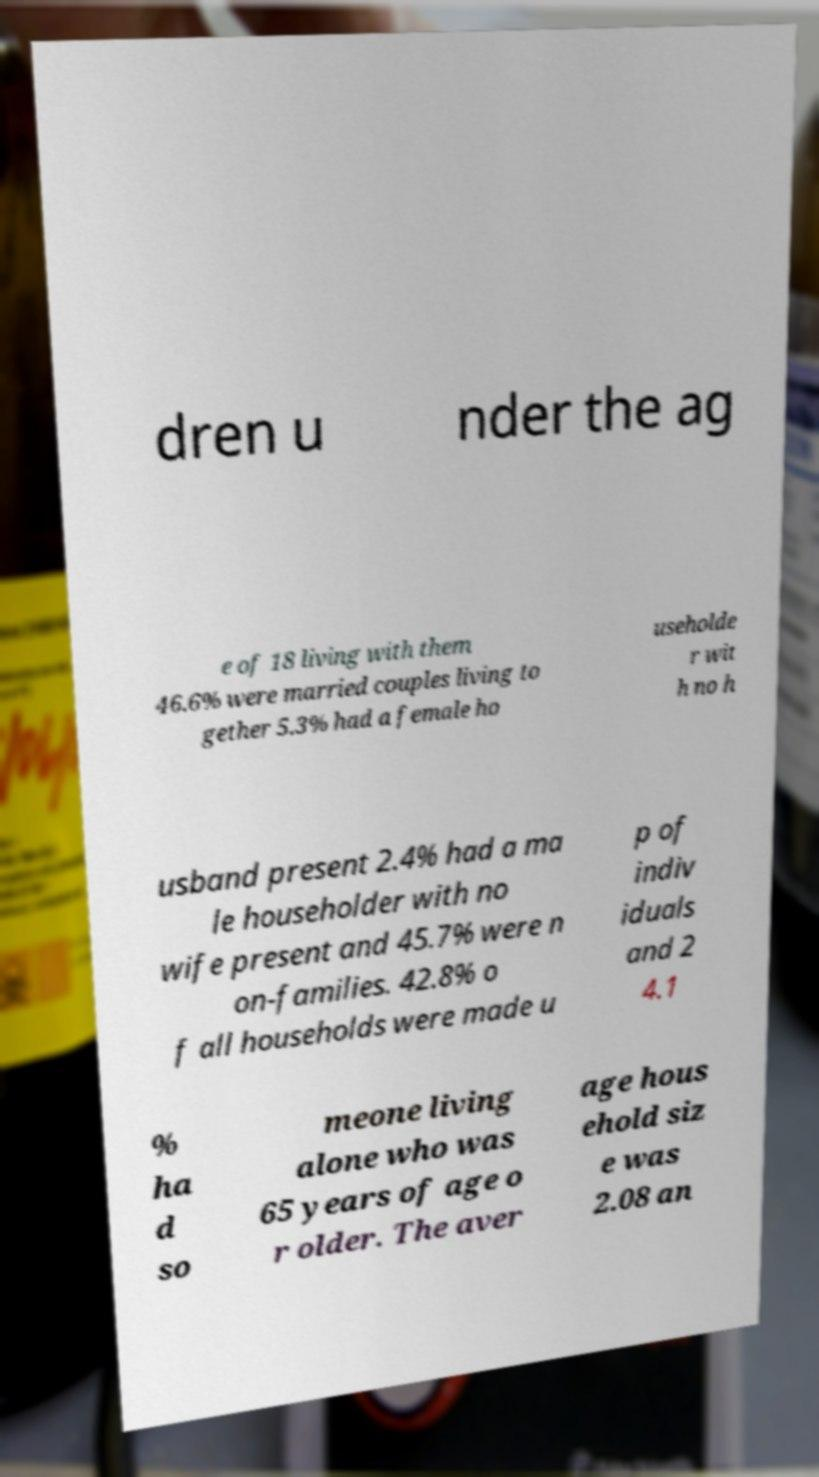I need the written content from this picture converted into text. Can you do that? dren u nder the ag e of 18 living with them 46.6% were married couples living to gether 5.3% had a female ho useholde r wit h no h usband present 2.4% had a ma le householder with no wife present and 45.7% were n on-families. 42.8% o f all households were made u p of indiv iduals and 2 4.1 % ha d so meone living alone who was 65 years of age o r older. The aver age hous ehold siz e was 2.08 an 